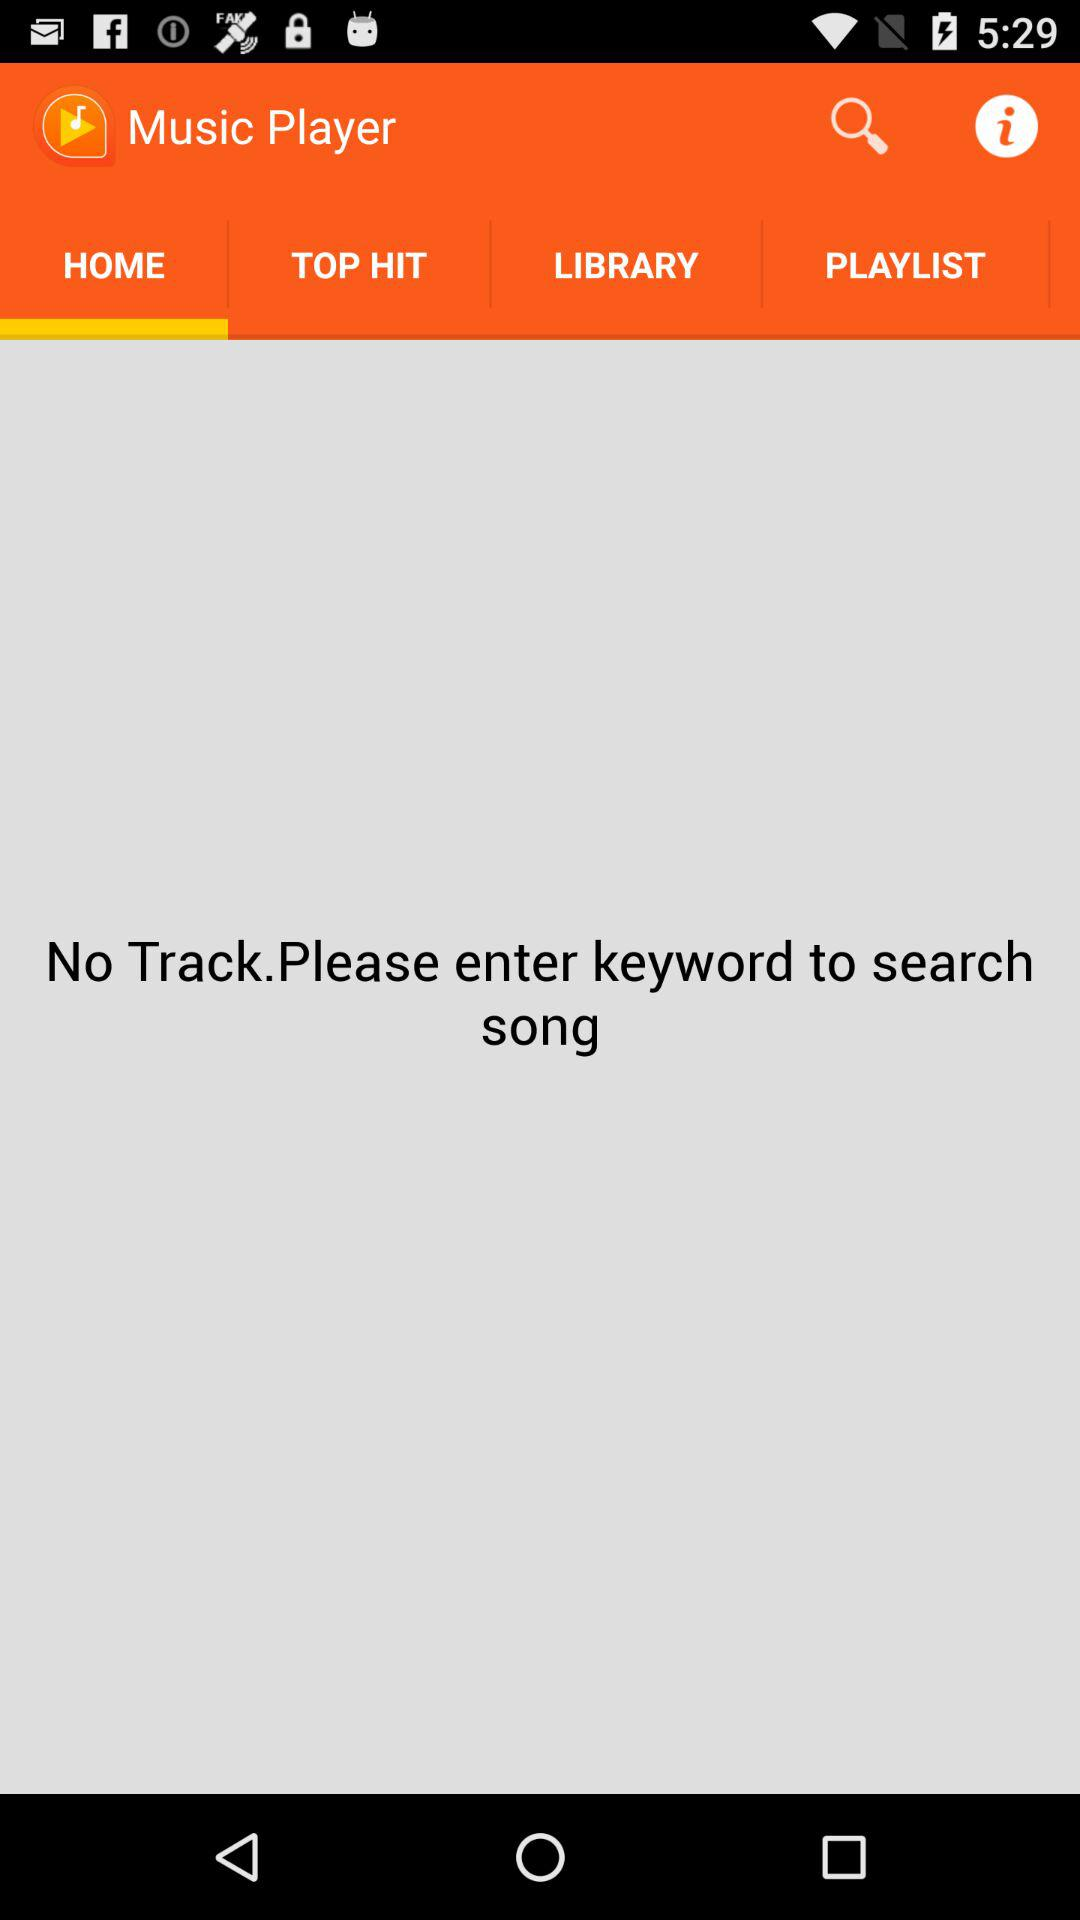Which tab is selected? The selected tab is "HOME". 